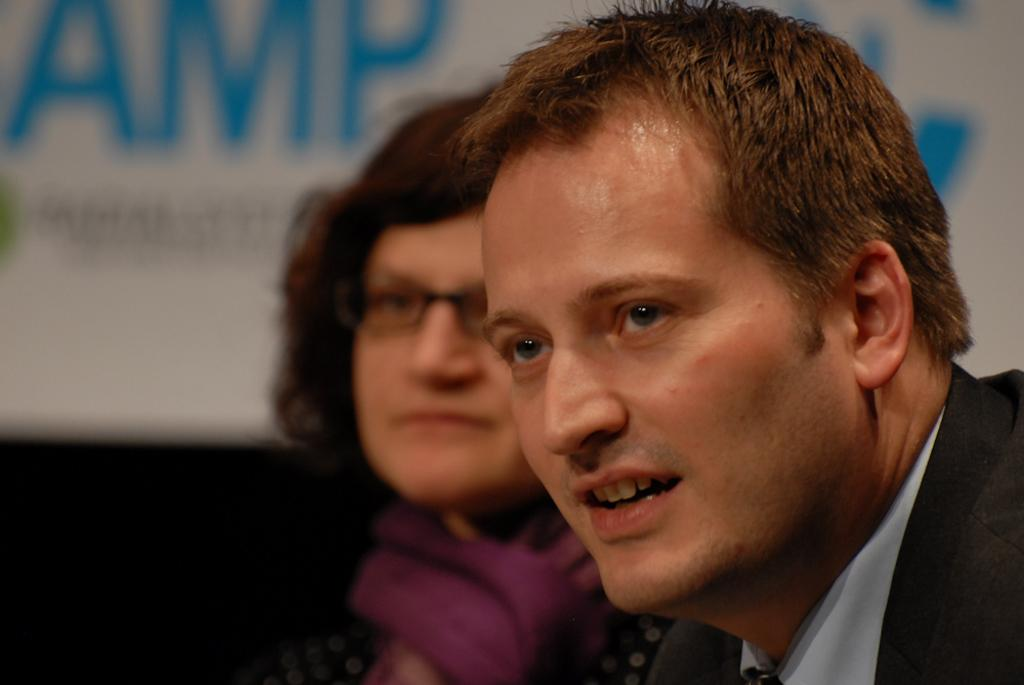Who are the main subjects in the image? There is a lady and a man in the center of the image. What can be seen in the background of the image? There is a board visible in the background of the image. What type of skin is the lady wearing in the image? The lady is not wearing skin; she is a person, and people have their own skin. 